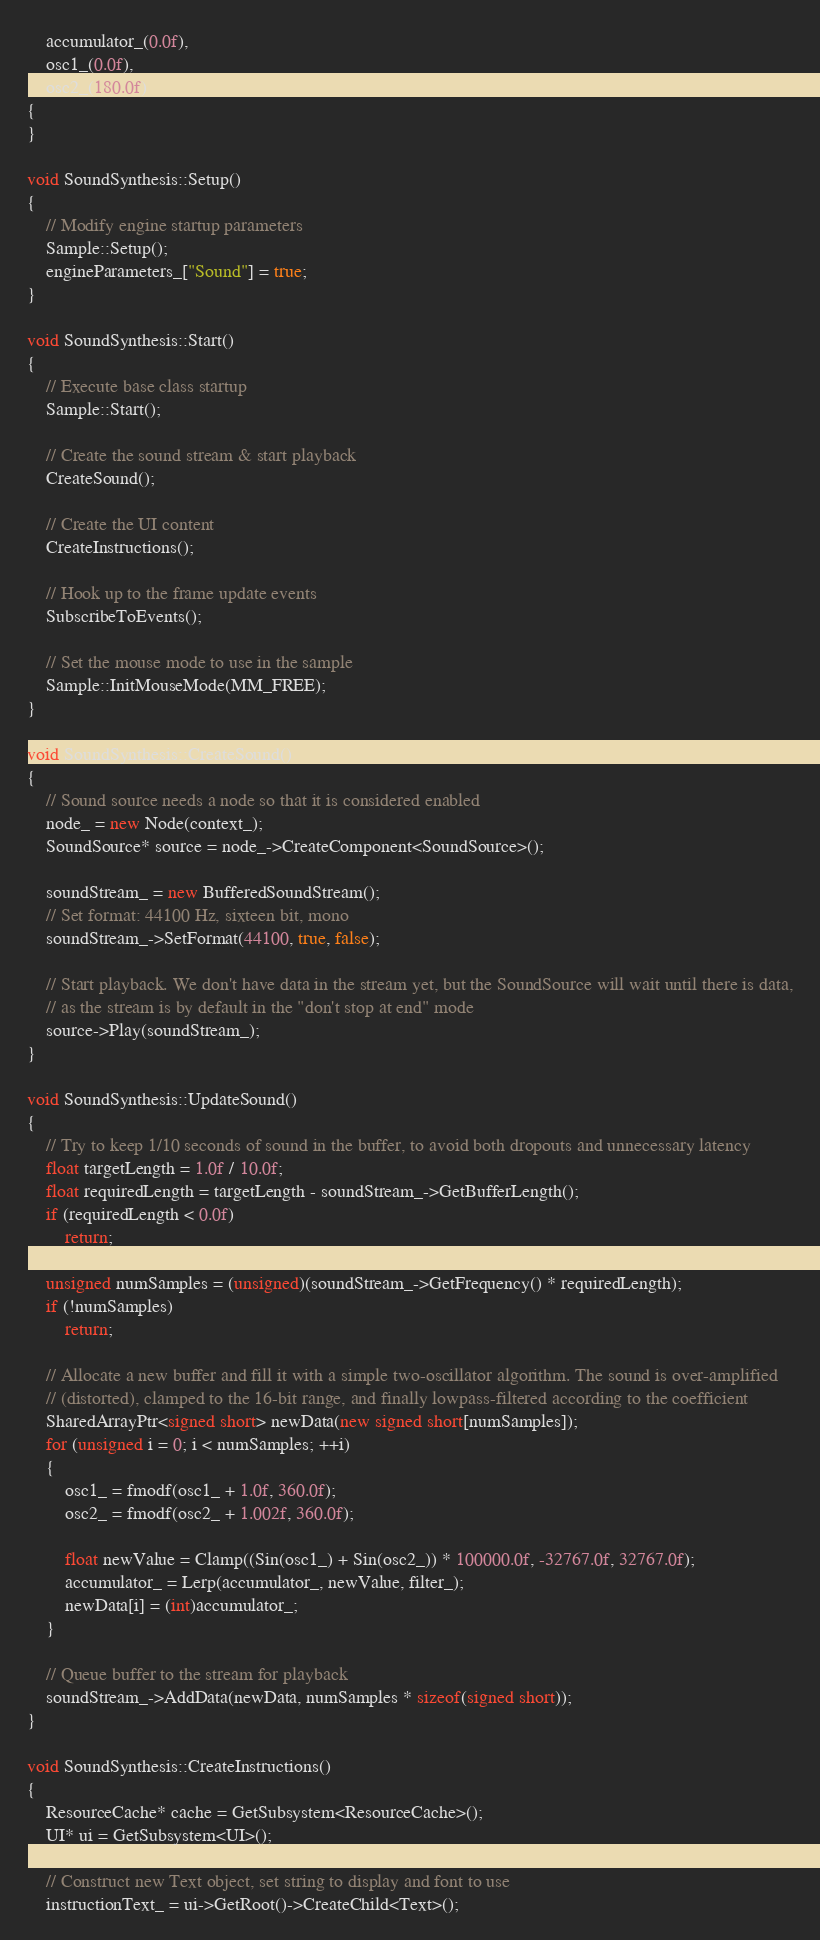<code> <loc_0><loc_0><loc_500><loc_500><_C++_>    accumulator_(0.0f),
    osc1_(0.0f),
    osc2_(180.0f)
{
}

void SoundSynthesis::Setup()
{
    // Modify engine startup parameters
    Sample::Setup();
    engineParameters_["Sound"] = true;
}

void SoundSynthesis::Start()
{
    // Execute base class startup
    Sample::Start();

    // Create the sound stream & start playback
    CreateSound();

    // Create the UI content
    CreateInstructions();

    // Hook up to the frame update events
    SubscribeToEvents();

    // Set the mouse mode to use in the sample
    Sample::InitMouseMode(MM_FREE);
}

void SoundSynthesis::CreateSound()
{
    // Sound source needs a node so that it is considered enabled
    node_ = new Node(context_);
    SoundSource* source = node_->CreateComponent<SoundSource>();

    soundStream_ = new BufferedSoundStream();
    // Set format: 44100 Hz, sixteen bit, mono
    soundStream_->SetFormat(44100, true, false);

    // Start playback. We don't have data in the stream yet, but the SoundSource will wait until there is data,
    // as the stream is by default in the "don't stop at end" mode
    source->Play(soundStream_);
}

void SoundSynthesis::UpdateSound()
{
    // Try to keep 1/10 seconds of sound in the buffer, to avoid both dropouts and unnecessary latency
    float targetLength = 1.0f / 10.0f;
    float requiredLength = targetLength - soundStream_->GetBufferLength();
    if (requiredLength < 0.0f)
        return;

    unsigned numSamples = (unsigned)(soundStream_->GetFrequency() * requiredLength);
    if (!numSamples)
        return;

    // Allocate a new buffer and fill it with a simple two-oscillator algorithm. The sound is over-amplified
    // (distorted), clamped to the 16-bit range, and finally lowpass-filtered according to the coefficient
    SharedArrayPtr<signed short> newData(new signed short[numSamples]);
    for (unsigned i = 0; i < numSamples; ++i)
    {
        osc1_ = fmodf(osc1_ + 1.0f, 360.0f);
        osc2_ = fmodf(osc2_ + 1.002f, 360.0f);

        float newValue = Clamp((Sin(osc1_) + Sin(osc2_)) * 100000.0f, -32767.0f, 32767.0f);
        accumulator_ = Lerp(accumulator_, newValue, filter_);
        newData[i] = (int)accumulator_;
    }

    // Queue buffer to the stream for playback
    soundStream_->AddData(newData, numSamples * sizeof(signed short));
}

void SoundSynthesis::CreateInstructions()
{
    ResourceCache* cache = GetSubsystem<ResourceCache>();
    UI* ui = GetSubsystem<UI>();

    // Construct new Text object, set string to display and font to use
    instructionText_ = ui->GetRoot()->CreateChild<Text>();</code> 